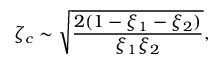Convert formula to latex. <formula><loc_0><loc_0><loc_500><loc_500>\zeta _ { c } \sim \sqrt { \frac { 2 ( 1 - \xi _ { 1 } - \xi _ { 2 } ) } { \xi _ { 1 } \xi _ { 2 } } } ,</formula> 